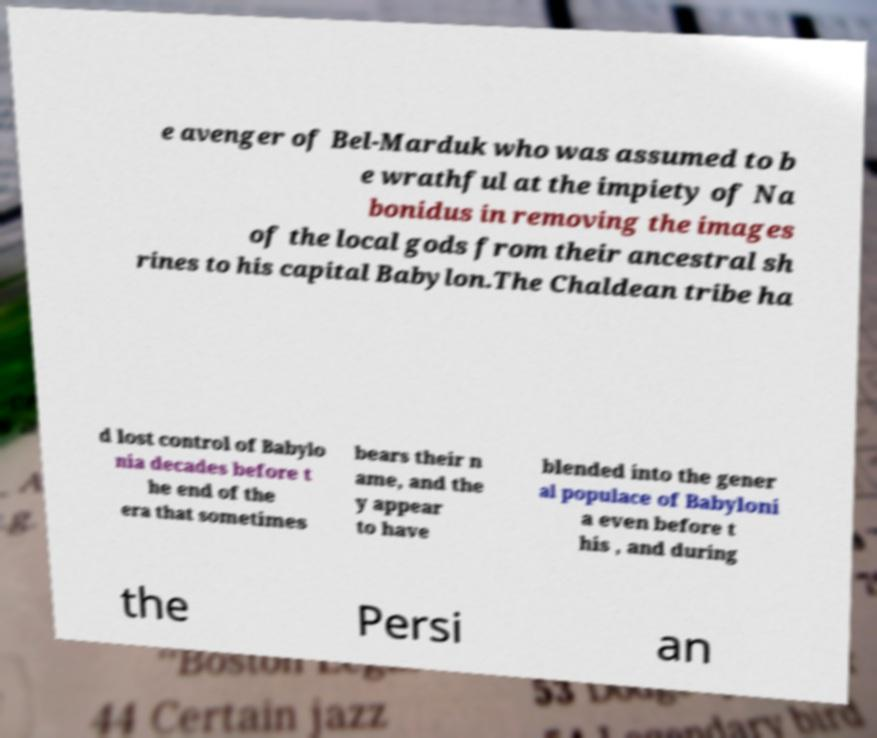Could you extract and type out the text from this image? e avenger of Bel-Marduk who was assumed to b e wrathful at the impiety of Na bonidus in removing the images of the local gods from their ancestral sh rines to his capital Babylon.The Chaldean tribe ha d lost control of Babylo nia decades before t he end of the era that sometimes bears their n ame, and the y appear to have blended into the gener al populace of Babyloni a even before t his , and during the Persi an 